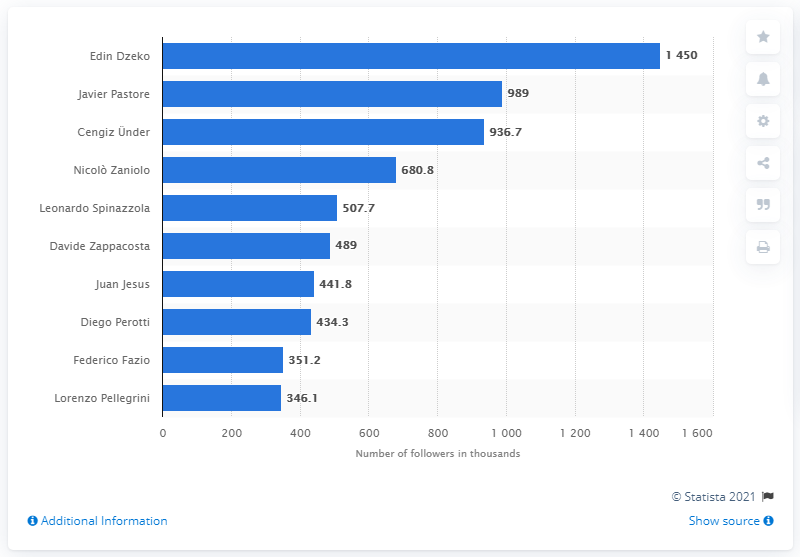Draw attention to some important aspects in this diagram. Javier Pastore was the second most popular Roma player on Instagram. As of May 29, 2020, Edin Dzeko was the most popular Roma player on Instagram. 